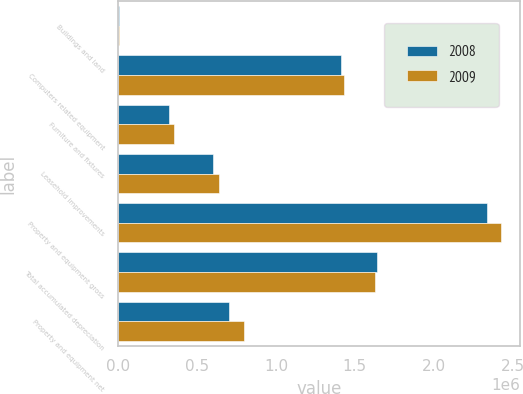Convert chart to OTSL. <chart><loc_0><loc_0><loc_500><loc_500><stacked_bar_chart><ecel><fcel>Buildings and land<fcel>Computers related equipment<fcel>Furniture and fixtures<fcel>Leasehold improvements<fcel>Property and equipment gross<fcel>Total accumulated depreciation<fcel>Property and equipment net<nl><fcel>2008<fcel>4286<fcel>1.41544e+06<fcel>320589<fcel>600701<fcel>2.34102e+06<fcel>1.63987e+06<fcel>701144<nl><fcel>2009<fcel>4424<fcel>1.42981e+06<fcel>353773<fcel>637841<fcel>2.42585e+06<fcel>1.62568e+06<fcel>800164<nl></chart> 